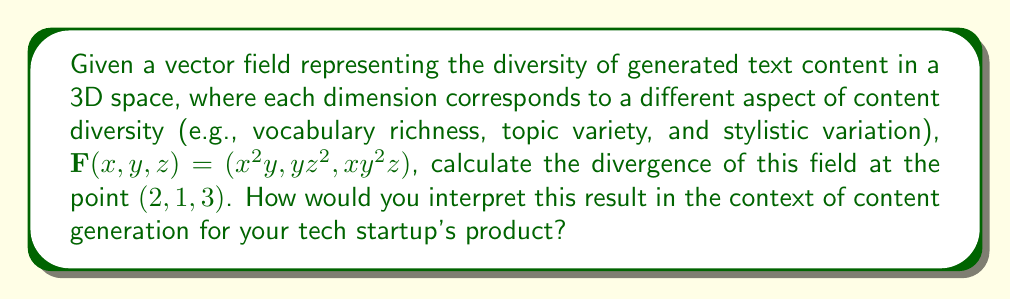Show me your answer to this math problem. To solve this problem, we'll follow these steps:

1) The divergence of a vector field $\mathbf{F}(x,y,z) = (F_1, F_2, F_3)$ is given by:

   $$\text{div}\mathbf{F} = \nabla \cdot \mathbf{F} = \frac{\partial F_1}{\partial x} + \frac{\partial F_2}{\partial y} + \frac{\partial F_3}{\partial z}$$

2) For our vector field $\mathbf{F}(x,y,z) = (x^2y, yz^2, xy^2z)$, we need to calculate:

   $$\frac{\partial}{\partial x}(x^2y) + \frac{\partial}{\partial y}(yz^2) + \frac{\partial}{\partial z}(xy^2z)$$

3) Let's calculate each partial derivative:
   
   $\frac{\partial}{\partial x}(x^2y) = 2xy$
   
   $\frac{\partial}{\partial y}(yz^2) = z^2$
   
   $\frac{\partial}{\partial z}(xy^2z) = xy^2$

4) Now, we can write the divergence as:

   $$\text{div}\mathbf{F} = 2xy + z^2 + xy^2$$

5) To find the divergence at the point $(2,1,3)$, we substitute these values:

   $$\text{div}\mathbf{F}(2,1,3) = 2(2)(1) + 3^2 + 2(1)^2 = 4 + 9 + 2 = 15$$

6) Interpretation: The positive divergence indicates that this point is a source in the vector field. In the context of content generation, this suggests that at this particular combination of vocabulary richness (x=2), topic variety (y=1), and stylistic variation (z=3), there's a high outflow or expansion of content diversity. This could mean that the text generation algorithm is particularly effective at producing diverse content under these conditions.
Answer: The divergence of the vector field at the point $(2,1,3)$ is 15. This positive value indicates a source in the field, suggesting high content diversity generation potential at this specific combination of vocabulary richness, topic variety, and stylistic variation. 